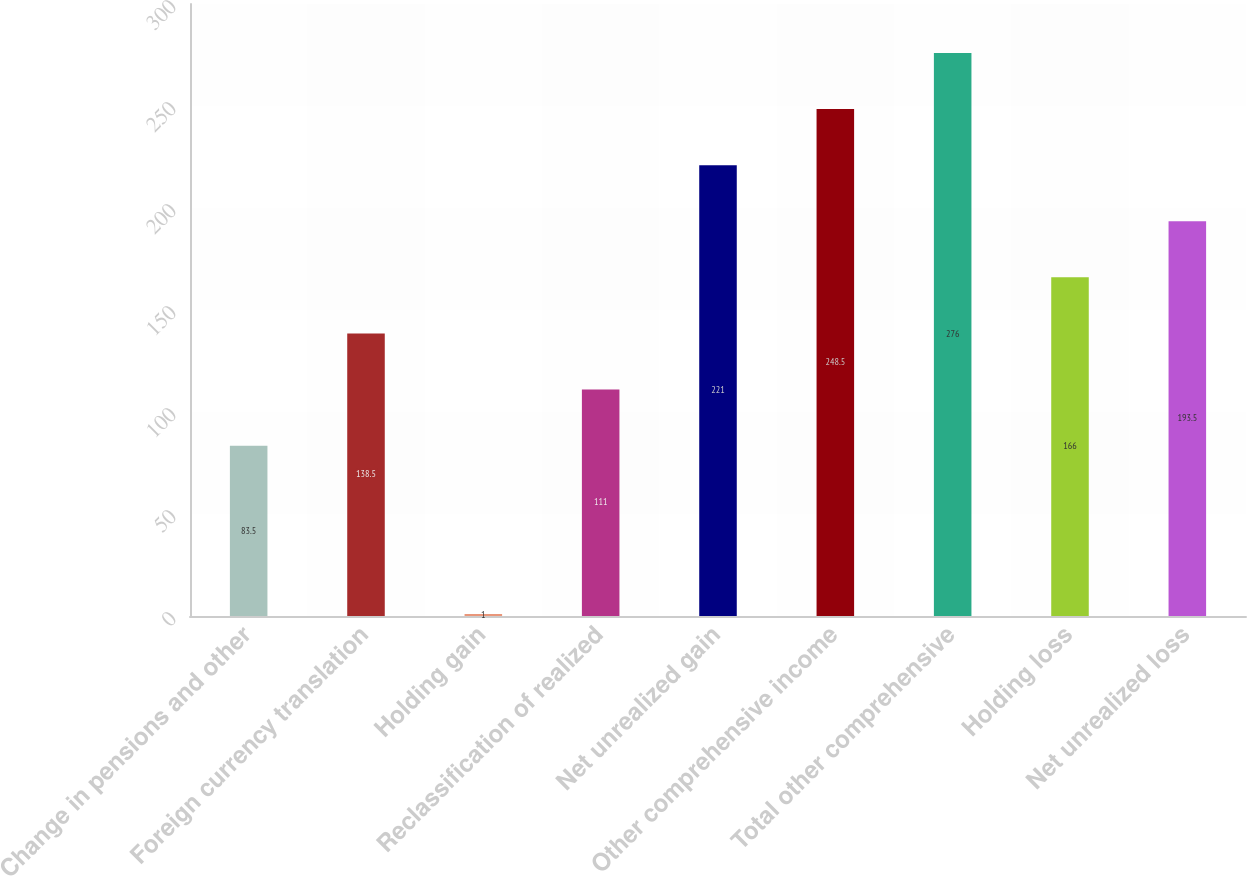<chart> <loc_0><loc_0><loc_500><loc_500><bar_chart><fcel>Change in pensions and other<fcel>Foreign currency translation<fcel>Holding gain<fcel>Reclassification of realized<fcel>Net unrealized gain<fcel>Other comprehensive income<fcel>Total other comprehensive<fcel>Holding loss<fcel>Net unrealized loss<nl><fcel>83.5<fcel>138.5<fcel>1<fcel>111<fcel>221<fcel>248.5<fcel>276<fcel>166<fcel>193.5<nl></chart> 